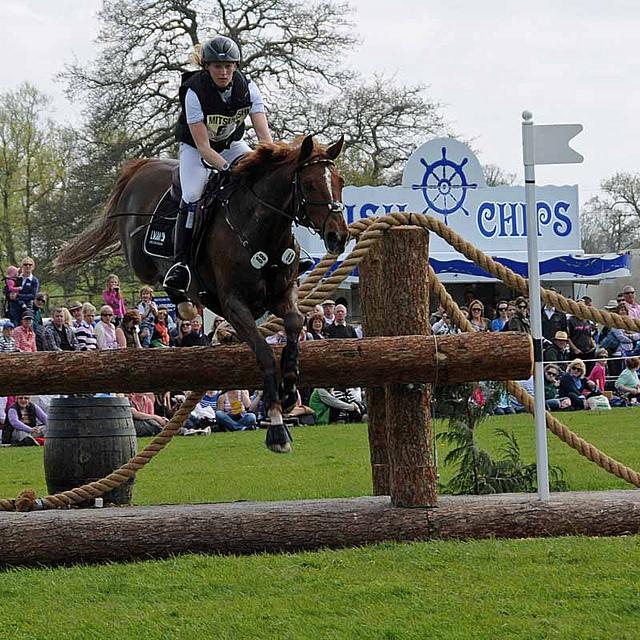What is horse jumping over?
Write a very short answer. Fence. Is the rider competing?
Give a very brief answer. Yes. Is there a wooden barrel behind the wood post?
Be succinct. Yes. 